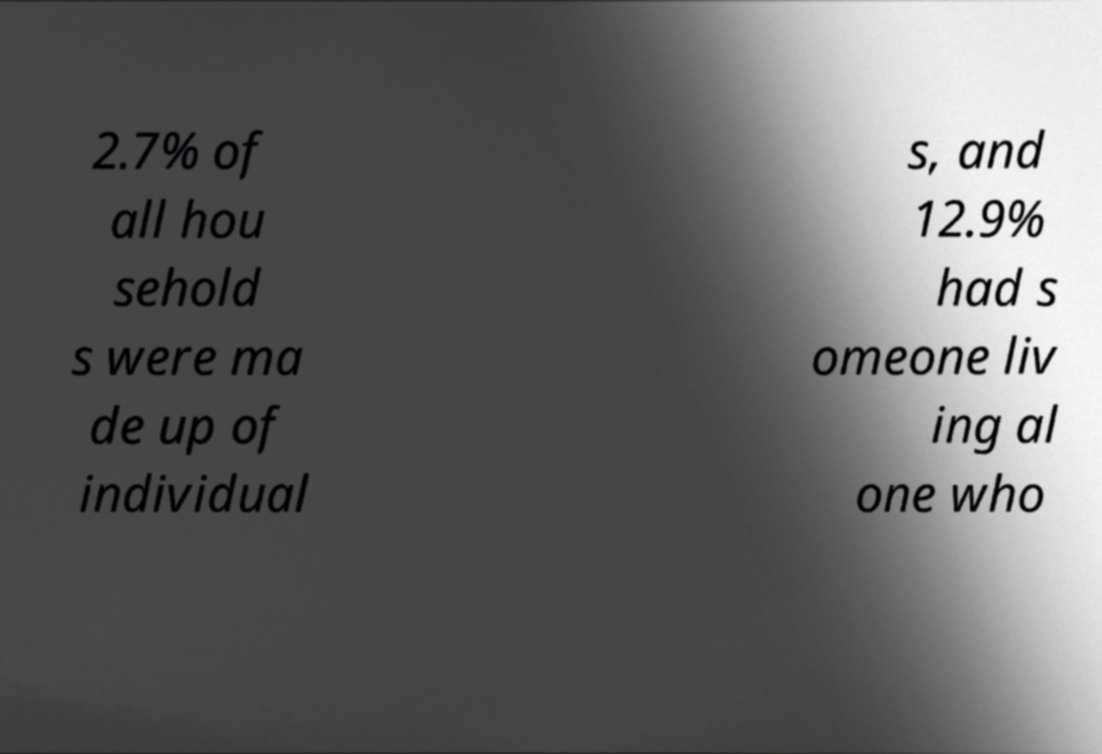Could you assist in decoding the text presented in this image and type it out clearly? 2.7% of all hou sehold s were ma de up of individual s, and 12.9% had s omeone liv ing al one who 